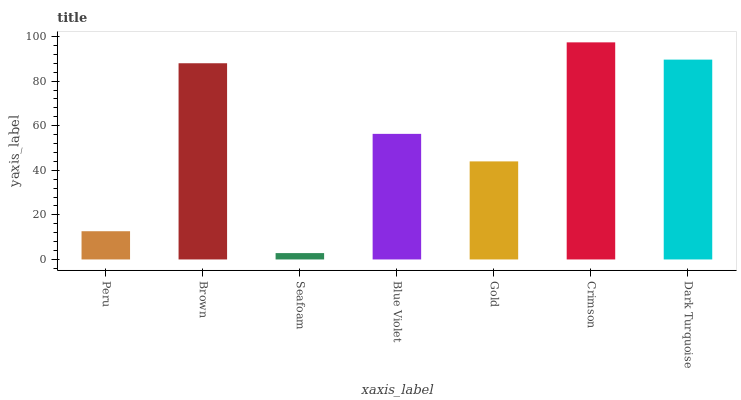Is Seafoam the minimum?
Answer yes or no. Yes. Is Crimson the maximum?
Answer yes or no. Yes. Is Brown the minimum?
Answer yes or no. No. Is Brown the maximum?
Answer yes or no. No. Is Brown greater than Peru?
Answer yes or no. Yes. Is Peru less than Brown?
Answer yes or no. Yes. Is Peru greater than Brown?
Answer yes or no. No. Is Brown less than Peru?
Answer yes or no. No. Is Blue Violet the high median?
Answer yes or no. Yes. Is Blue Violet the low median?
Answer yes or no. Yes. Is Brown the high median?
Answer yes or no. No. Is Seafoam the low median?
Answer yes or no. No. 